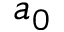Convert formula to latex. <formula><loc_0><loc_0><loc_500><loc_500>a _ { 0 }</formula> 